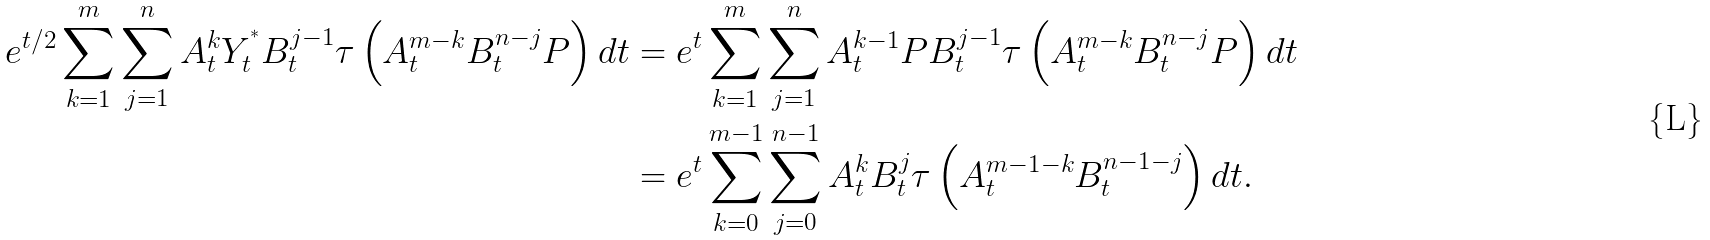<formula> <loc_0><loc_0><loc_500><loc_500>e ^ { t / 2 } \sum _ { k = 1 } ^ { m } \sum _ { j = 1 } ^ { n } A _ { t } ^ { k } Y _ { t } ^ { ^ { * } } B _ { t } ^ { j - 1 } \tau \left ( A _ { t } ^ { m - k } B _ { t } ^ { n - j } P \right ) d t & = e ^ { t } \sum _ { k = 1 } ^ { m } \sum _ { j = 1 } ^ { n } A _ { t } ^ { k - 1 } P B _ { t } ^ { j - 1 } \tau \left ( A _ { t } ^ { m - k } B _ { t } ^ { n - j } P \right ) d t \\ & = e ^ { t } \sum _ { k = 0 } ^ { m - 1 } \sum _ { j = 0 } ^ { n - 1 } A _ { t } ^ { k } B _ { t } ^ { j } \tau \left ( A _ { t } ^ { m - 1 - k } B _ { t } ^ { n - 1 - j } \right ) d t .</formula> 